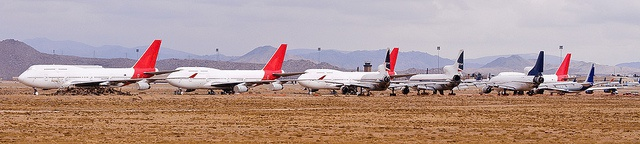Describe the objects in this image and their specific colors. I can see airplane in lightgray, red, and darkgray tones, airplane in lightgray, white, darkgray, red, and black tones, airplane in lightgray, darkgray, black, and gray tones, airplane in lightgray, darkgray, black, and navy tones, and airplane in lightgray, black, darkgray, and gray tones in this image. 